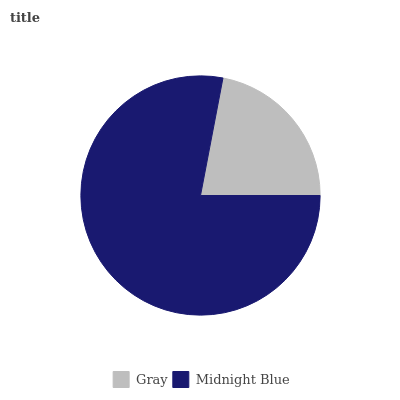Is Gray the minimum?
Answer yes or no. Yes. Is Midnight Blue the maximum?
Answer yes or no. Yes. Is Midnight Blue the minimum?
Answer yes or no. No. Is Midnight Blue greater than Gray?
Answer yes or no. Yes. Is Gray less than Midnight Blue?
Answer yes or no. Yes. Is Gray greater than Midnight Blue?
Answer yes or no. No. Is Midnight Blue less than Gray?
Answer yes or no. No. Is Midnight Blue the high median?
Answer yes or no. Yes. Is Gray the low median?
Answer yes or no. Yes. Is Gray the high median?
Answer yes or no. No. Is Midnight Blue the low median?
Answer yes or no. No. 